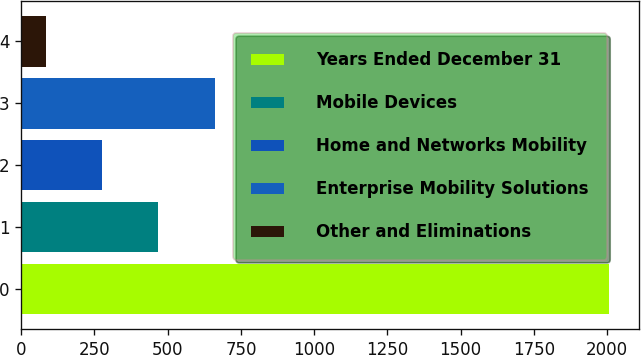Convert chart to OTSL. <chart><loc_0><loc_0><loc_500><loc_500><bar_chart><fcel>Years Ended December 31<fcel>Mobile Devices<fcel>Home and Networks Mobility<fcel>Enterprise Mobility Solutions<fcel>Other and Eliminations<nl><fcel>2007<fcel>467.8<fcel>275.4<fcel>660.2<fcel>83<nl></chart> 